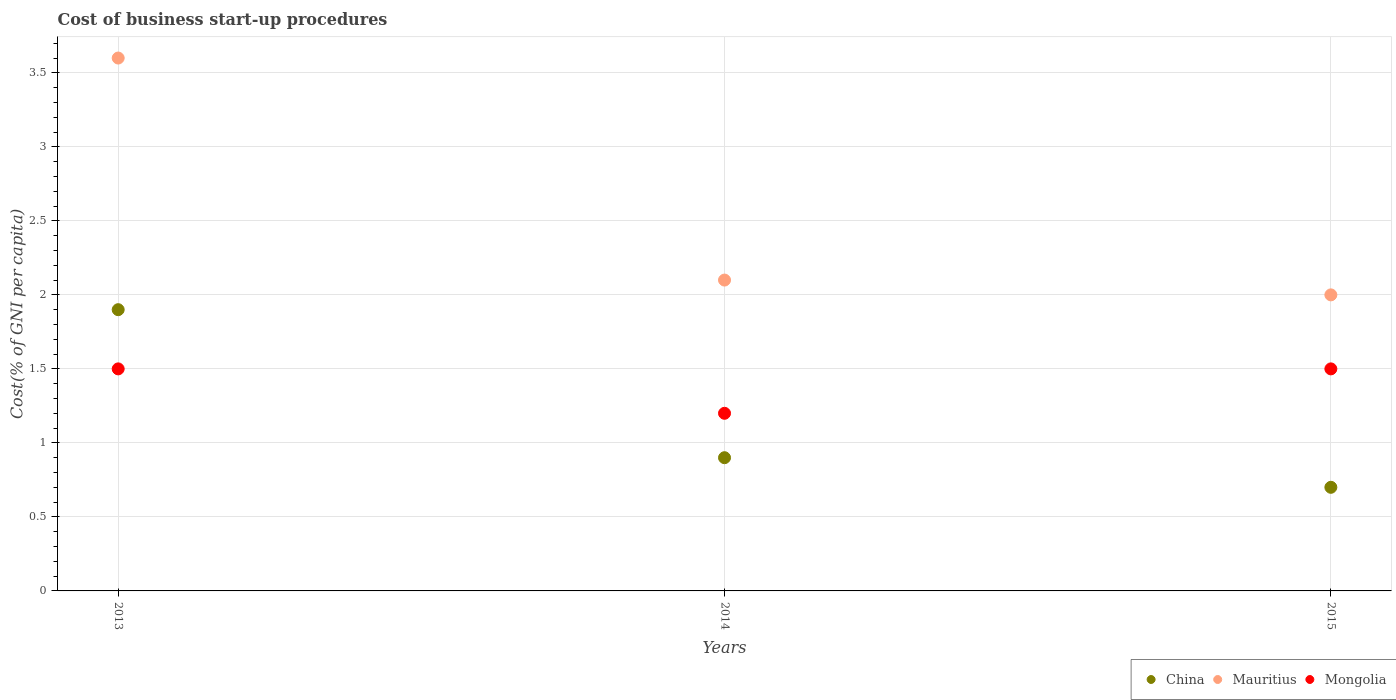How many different coloured dotlines are there?
Your answer should be compact. 3. Is the number of dotlines equal to the number of legend labels?
Your answer should be compact. Yes. What is the cost of business start-up procedures in Mongolia in 2015?
Make the answer very short. 1.5. Across all years, what is the maximum cost of business start-up procedures in China?
Offer a very short reply. 1.9. Across all years, what is the minimum cost of business start-up procedures in Mauritius?
Offer a terse response. 2. In which year was the cost of business start-up procedures in Mongolia maximum?
Provide a succinct answer. 2013. In which year was the cost of business start-up procedures in Mongolia minimum?
Your answer should be very brief. 2014. What is the difference between the cost of business start-up procedures in Mongolia in 2013 and that in 2014?
Provide a short and direct response. 0.3. What is the difference between the cost of business start-up procedures in Mongolia in 2015 and the cost of business start-up procedures in Mauritius in 2014?
Make the answer very short. -0.6. What is the average cost of business start-up procedures in Mongolia per year?
Your answer should be very brief. 1.4. In how many years, is the cost of business start-up procedures in China greater than 0.6 %?
Offer a very short reply. 3. What is the ratio of the cost of business start-up procedures in Mongolia in 2014 to that in 2015?
Your answer should be very brief. 0.8. What is the difference between the highest and the lowest cost of business start-up procedures in Mongolia?
Your answer should be very brief. 0.3. In how many years, is the cost of business start-up procedures in Mauritius greater than the average cost of business start-up procedures in Mauritius taken over all years?
Your answer should be very brief. 1. Does the cost of business start-up procedures in Mongolia monotonically increase over the years?
Ensure brevity in your answer.  No. Are the values on the major ticks of Y-axis written in scientific E-notation?
Make the answer very short. No. Where does the legend appear in the graph?
Offer a very short reply. Bottom right. How many legend labels are there?
Keep it short and to the point. 3. What is the title of the graph?
Provide a short and direct response. Cost of business start-up procedures. Does "Costa Rica" appear as one of the legend labels in the graph?
Give a very brief answer. No. What is the label or title of the X-axis?
Your answer should be compact. Years. What is the label or title of the Y-axis?
Provide a short and direct response. Cost(% of GNI per capita). What is the Cost(% of GNI per capita) of Mauritius in 2013?
Provide a short and direct response. 3.6. What is the Cost(% of GNI per capita) of Mongolia in 2013?
Offer a terse response. 1.5. What is the Cost(% of GNI per capita) in Mauritius in 2014?
Ensure brevity in your answer.  2.1. What is the Cost(% of GNI per capita) in Mongolia in 2014?
Offer a very short reply. 1.2. What is the Cost(% of GNI per capita) in China in 2015?
Provide a succinct answer. 0.7. What is the Cost(% of GNI per capita) in Mongolia in 2015?
Your answer should be very brief. 1.5. Across all years, what is the maximum Cost(% of GNI per capita) in Mauritius?
Ensure brevity in your answer.  3.6. Across all years, what is the maximum Cost(% of GNI per capita) in Mongolia?
Keep it short and to the point. 1.5. Across all years, what is the minimum Cost(% of GNI per capita) of China?
Your response must be concise. 0.7. Across all years, what is the minimum Cost(% of GNI per capita) in Mauritius?
Ensure brevity in your answer.  2. Across all years, what is the minimum Cost(% of GNI per capita) in Mongolia?
Keep it short and to the point. 1.2. What is the total Cost(% of GNI per capita) of Mauritius in the graph?
Give a very brief answer. 7.7. What is the difference between the Cost(% of GNI per capita) in Mauritius in 2013 and that in 2014?
Your response must be concise. 1.5. What is the difference between the Cost(% of GNI per capita) of Mongolia in 2013 and that in 2014?
Provide a short and direct response. 0.3. What is the difference between the Cost(% of GNI per capita) in China in 2013 and that in 2015?
Your response must be concise. 1.2. What is the difference between the Cost(% of GNI per capita) in Mauritius in 2014 and that in 2015?
Your answer should be compact. 0.1. What is the difference between the Cost(% of GNI per capita) in Mongolia in 2014 and that in 2015?
Provide a short and direct response. -0.3. What is the difference between the Cost(% of GNI per capita) in China in 2013 and the Cost(% of GNI per capita) in Mongolia in 2014?
Provide a short and direct response. 0.7. What is the difference between the Cost(% of GNI per capita) in Mauritius in 2013 and the Cost(% of GNI per capita) in Mongolia in 2014?
Make the answer very short. 2.4. What is the difference between the Cost(% of GNI per capita) in China in 2013 and the Cost(% of GNI per capita) in Mongolia in 2015?
Provide a short and direct response. 0.4. What is the difference between the Cost(% of GNI per capita) in China in 2014 and the Cost(% of GNI per capita) in Mauritius in 2015?
Offer a very short reply. -1.1. What is the difference between the Cost(% of GNI per capita) of China in 2014 and the Cost(% of GNI per capita) of Mongolia in 2015?
Keep it short and to the point. -0.6. What is the average Cost(% of GNI per capita) in Mauritius per year?
Your answer should be very brief. 2.57. In the year 2013, what is the difference between the Cost(% of GNI per capita) of China and Cost(% of GNI per capita) of Mongolia?
Offer a terse response. 0.4. In the year 2014, what is the difference between the Cost(% of GNI per capita) of China and Cost(% of GNI per capita) of Mauritius?
Offer a very short reply. -1.2. In the year 2014, what is the difference between the Cost(% of GNI per capita) of China and Cost(% of GNI per capita) of Mongolia?
Provide a succinct answer. -0.3. In the year 2015, what is the difference between the Cost(% of GNI per capita) of Mauritius and Cost(% of GNI per capita) of Mongolia?
Provide a succinct answer. 0.5. What is the ratio of the Cost(% of GNI per capita) in China in 2013 to that in 2014?
Offer a terse response. 2.11. What is the ratio of the Cost(% of GNI per capita) in Mauritius in 2013 to that in 2014?
Ensure brevity in your answer.  1.71. What is the ratio of the Cost(% of GNI per capita) of China in 2013 to that in 2015?
Offer a terse response. 2.71. What is the ratio of the Cost(% of GNI per capita) in Mauritius in 2013 to that in 2015?
Your answer should be compact. 1.8. What is the ratio of the Cost(% of GNI per capita) in Mongolia in 2013 to that in 2015?
Your answer should be very brief. 1. What is the ratio of the Cost(% of GNI per capita) of Mongolia in 2014 to that in 2015?
Your answer should be very brief. 0.8. What is the difference between the highest and the second highest Cost(% of GNI per capita) in China?
Your answer should be very brief. 1. What is the difference between the highest and the lowest Cost(% of GNI per capita) of China?
Ensure brevity in your answer.  1.2. What is the difference between the highest and the lowest Cost(% of GNI per capita) of Mongolia?
Make the answer very short. 0.3. 